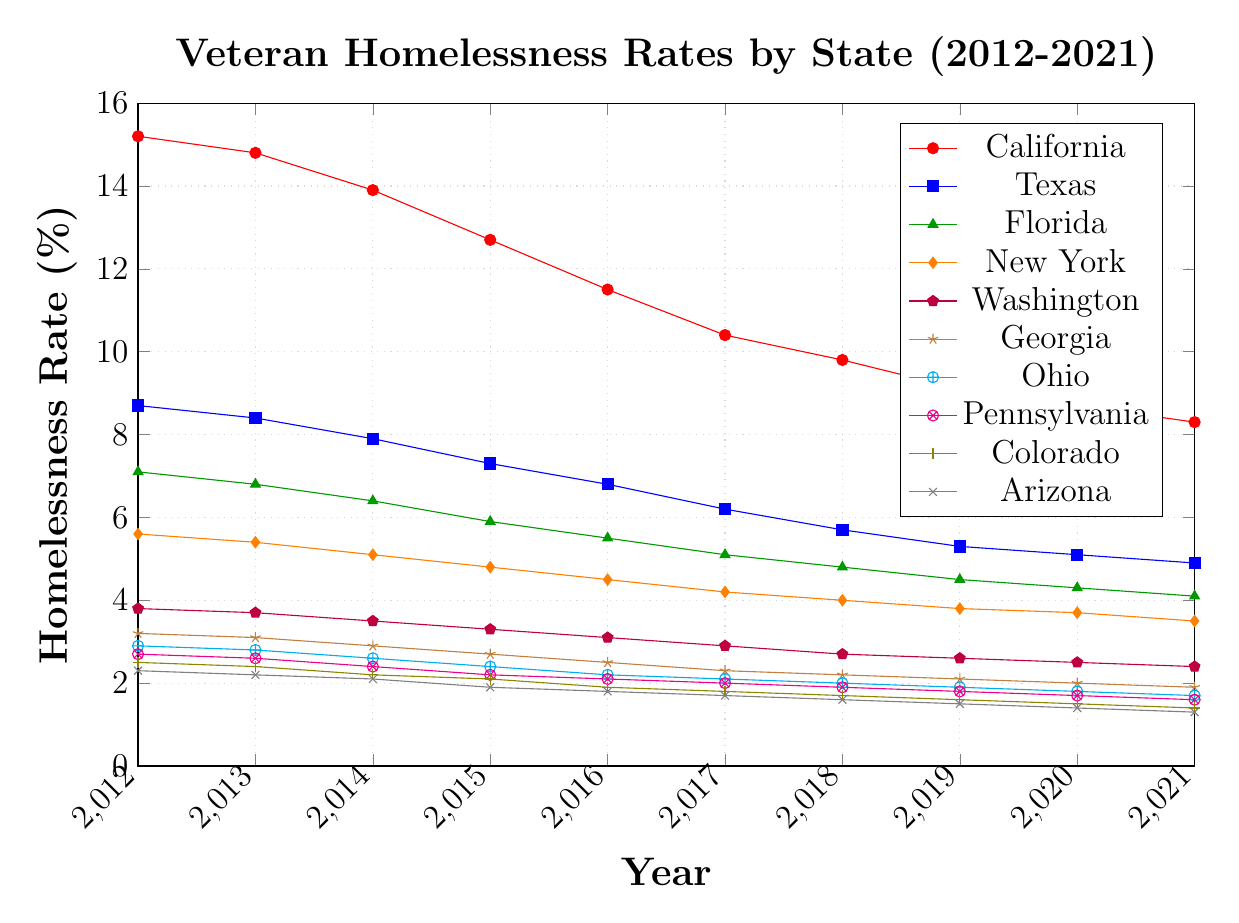Which state had the highest veteran homelessness rate in 2012? Look at the 2012 data points for all states and identify the state with the highest value. The highest rate in 2012 is for California at 15.2%.
Answer: California Which state saw the largest decrease in veteran homelessness rate from 2012 to 2021? Subtract the 2021 rate from the 2012 rate for each state and determine which has the largest difference. California had the highest decrease from 15.2% in 2012 to 8.3% in 2021, a decrease of 6.9%.
Answer: California By how many percentage points did the veteran homelessness rate decrease in Texas from 2012 to 2016? Subtract the 2016 rate from the 2012 rate for Texas. The decrease is 8.7% - 6.8% = 1.9%.
Answer: 1.9 Which state had the lowest veteran homelessness rate in 2021? Look at the 2021 data points for all states and identify the state with the lowest value. Arizona had the lowest rate at 1.3%.
Answer: Arizona Which states had veteran homelessness rates below 2% in 2021? Identify states with 2021 rates less than 2%. The states are Georgia, Ohio, Pennsylvania, Colorado, and Arizona, with rates 1.9%, 1.7%, 1.6%, 1.4%, and 1.3% respectively.
Answer: Georgia, Ohio, Pennsylvania, Colorado, Arizona What was the average veteran homelessness rate in 2015 for New York and Florida? Take the 2015 data points for New York and Florida, sum them up and divide by 2. The average rate is (4.8% + 5.9%) / 2 = 5.35%.
Answer: 5.35 During which year did Washington's veteran homelessness rate first drop below 3%? Find the first year in Washington's data where the rate is below 3%. In 2016, the rate is 2.9%, which is the first instance.
Answer: 2016 Compare the trend of veteran homelessness rates in California and Florida from 2012 to 2021. Which state had a steeper decline? Calculate the difference between 2012 and 2021 for both states. California's rate decreased by 6.9% (15.2% - 8.3%) and Florida's by 3% (7.1% - 4.1%). California had a steeper decline.
Answer: California What is the total percentage point decrease for Pennsylvania from 2012 to 2021? Subtract the 2021 rate from the 2012 rate for Pennsylvania. The total decrease is 2.7% - 1.6% = 1.1%.
Answer: 1.1 Which state saw the smallest decrease in veteran homelessness rate from 2012 to 2021? Subtract the 2021 rate from the 2012 rate for each state and determine which has the smallest difference. Washington had the smallest decrease from 3.8% to 2.4%, a decrease of 1.4%.
Answer: Washington 